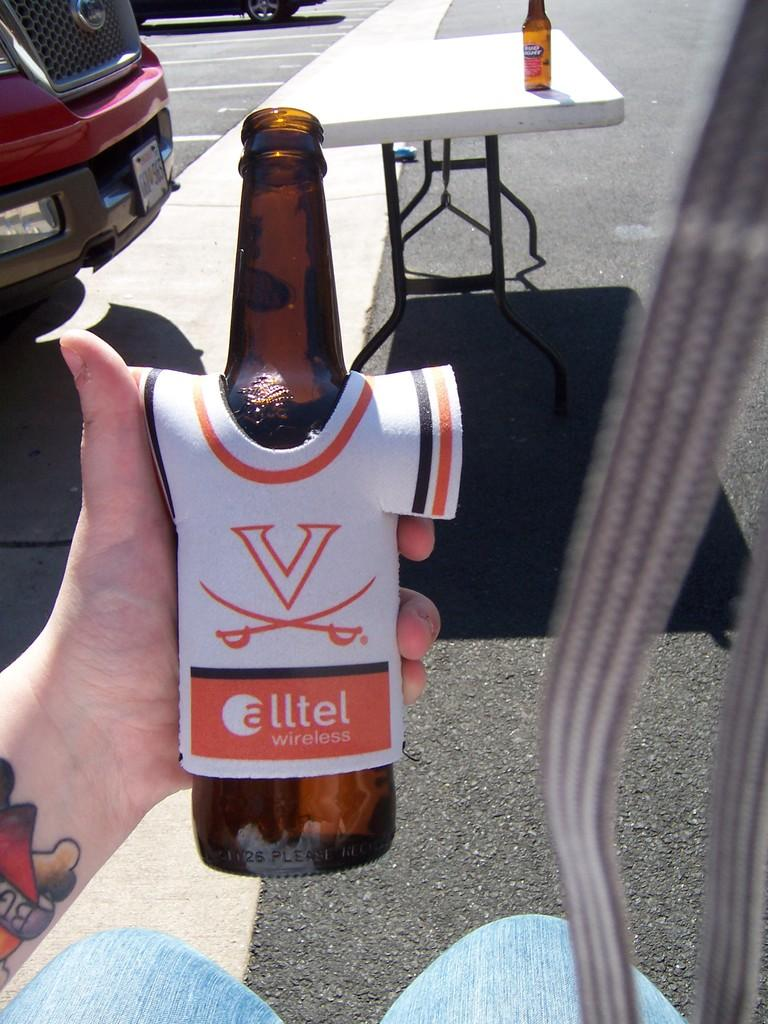What object is being held by a person's hand in the image? There is a bottle in the image that is being held by a person's hand. What can be seen in the background of the image? There are vehicles visible in the background of the image. Are there any other bottles present in the image? Yes, there is another bottle on a table in the image. Where is the nest located in the image? There is no nest present in the image. What type of glass is being used to hold the bottle in the image? The image does not show any glass being used to hold the bottle; it is being held by a person's hand. 